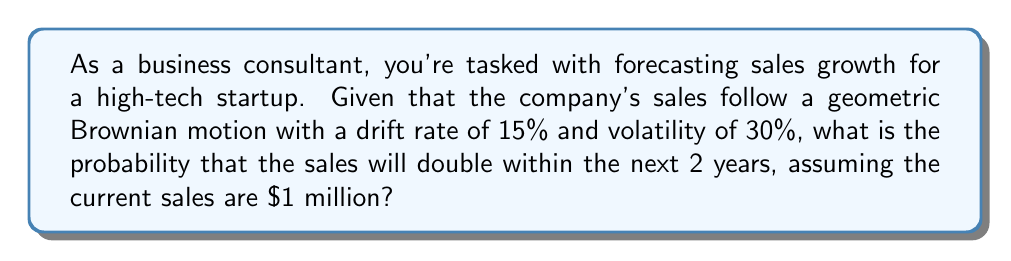Teach me how to tackle this problem. Let's approach this step-by-step using stochastic differential equations:

1) The geometric Brownian motion for sales $S_t$ is given by:

   $$dS_t = \mu S_t dt + \sigma S_t dW_t$$

   where $\mu$ is the drift rate, $\sigma$ is the volatility, and $W_t$ is a Wiener process.

2) We're given: $\mu = 15\% = 0.15$, $\sigma = 30\% = 0.3$, and $T = 2$ years.

3) For the sales to double, we need $S_T / S_0 = 2$. Taking logarithms:

   $$\ln(S_T/S_0) = \ln(2)$$

4) For geometric Brownian motion, $\ln(S_T/S_0)$ follows a normal distribution with:

   Mean: $(\mu - \frac{\sigma^2}{2})T$
   Variance: $\sigma^2 T$

5) Calculate these values:

   Mean = $(0.15 - \frac{0.3^2}{2}) * 2 = 0.21$
   Variance = $0.3^2 * 2 = 0.18$
   Standard Deviation = $\sqrt{0.18} = 0.4243$

6) We need to find $P(\ln(S_T/S_0) > \ln(2))$. Standardizing:

   $$P\left(\frac{\ln(S_T/S_0) - 0.21}{0.4243} > \frac{\ln(2) - 0.21}{0.4243}\right)$$

7) This is equivalent to $P(Z > 0.8128)$, where Z is a standard normal variable.

8) Using the standard normal table or a calculator:

   $P(Z > 0.8128) = 1 - P(Z < 0.8128) = 1 - 0.7918 = 0.2082$

Therefore, the probability that the sales will double within 2 years is approximately 0.2082 or 20.82%.
Answer: 0.2082 